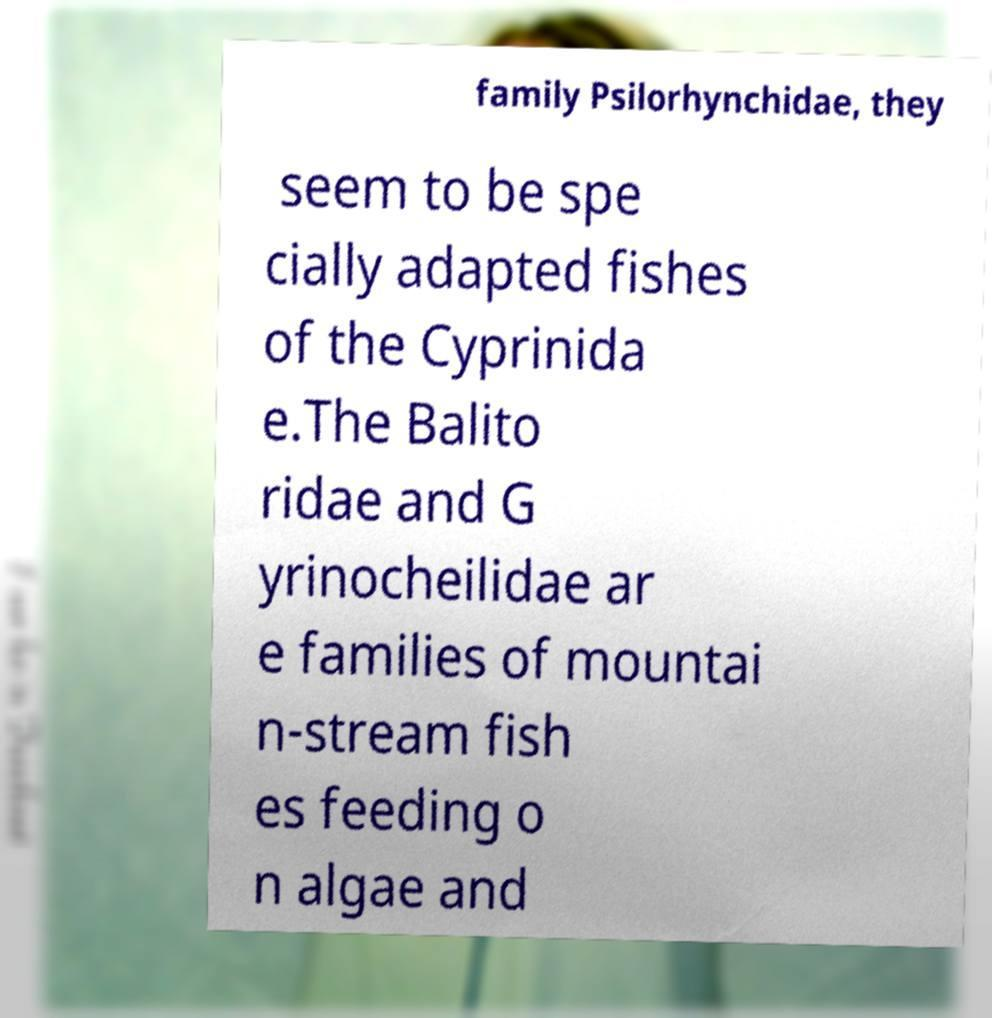Could you assist in decoding the text presented in this image and type it out clearly? family Psilorhynchidae, they seem to be spe cially adapted fishes of the Cyprinida e.The Balito ridae and G yrinocheilidae ar e families of mountai n-stream fish es feeding o n algae and 